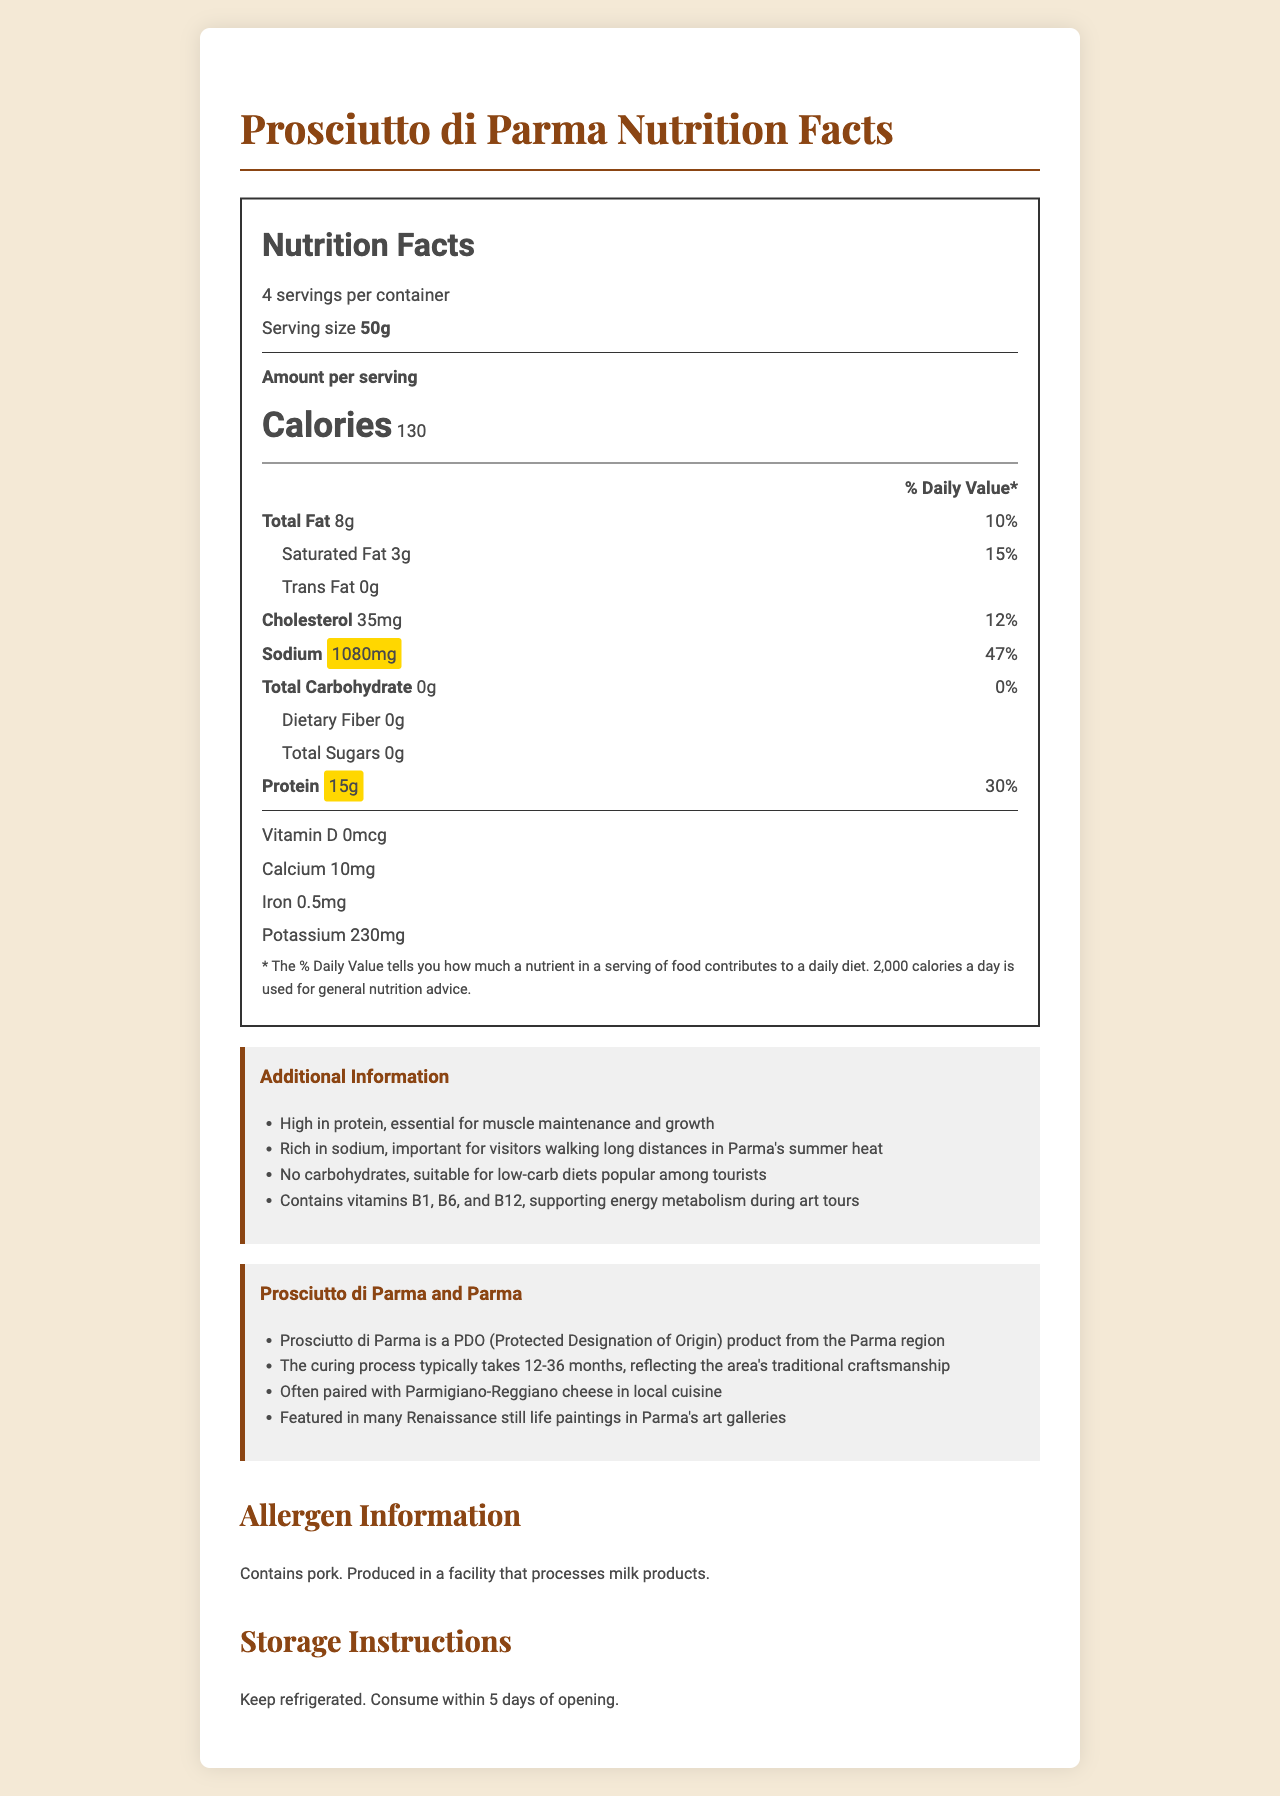what is the serving size for Prosciutto di Parma? The serving size is clearly stated as 50g in the document.
Answer: 50g how much protein does one serving of Prosciutto di Parma contain? The document indicates that each serving of Prosciutto di Parma contains 15g of protein.
Answer: 15g what is the daily value percentage of sodium in one serving? The sodium daily value percentage for one serving is given as 47% in the document.
Answer: 47% how many servings are in one container of Prosciutto di Parma? The document states that there are 4 servings per container.
Answer: 4 what is the cholesterol content per serving? Each serving contains 35mg of cholesterol as specified in the document.
Answer: 35mg which vitamin content is zero in Prosciutto di Parma? A. Vitamin D B. Vitamin C C. Calcium The document lists Vitamin D as having 0mcg.
Answer: A how does Prosciutto di Parma compare in sodium content with other typical foods? A. Low sodium B. Moderate sodium C. High sodium The highlighted amount of 1080mg of sodium per serving indicates it is high in sodium.
Answer: C can Prosciutto di Parma be a good option for a low-carb diet? Yes/No The document notes that Prosciutto di Parma contains 0g of total carbohydrates, making it suitable for low-carb diets.
Answer: Yes describe the main information provided in the document. The document outlines nutritional content, serving details, allergen and storage information, and provides cultural context.
Answer: The document provides detailed nutrition facts for Prosciutto di Parma, including serving size, calorie count, and the amounts and daily values of various nutrients such as fat, cholesterol, sodium, and protein. Additionally, it contains information on allergens, storage instructions, and its cultural significance and usage in Parma. what is the iron content per serving? The document states that each serving contains 0.5mg of iron.
Answer: 0.5mg what is the recommended storage instruction after opening? The storage instructions listed in the document are to keep the product refrigerated and consume it within 5 days of opening.
Answer: Keep refrigerated and consume within 5 days of opening. why is the sodium level highlighted in the nutrition facts? The sodium content is highlighted to emphasize that it is significantly high, making up 47% of the daily recommended value.
Answer: It's high at 1080mg per serving, contributing to 47% of the daily value. which vitamins are mentioned in the additional information but not listed in the nutrition facts table? A. B1, B6, and B12 B. A, C, and D C. D, E, and K The additional information section mentions B1, B6, and B12 vitamins, which are not detailed in the nutrition facts table.
Answer: A what is the daily value percentage of protein per serving? The daily value percentage for protein given in the document is 30%.
Answer: 30% can you determine how many grams of total carbohydrates are in a serving? The total carbohydrate content per serving is clearly stated as 0g in the document.
Answer: 0g what is the main use case of high sodium content, as mentioned in the document? The document mentions that the high sodium content is significant for visitors walking long distances in the summer heat of Parma.
Answer: Important for visitors walking long distances in Parma's summer heat. is Prosciutto di Parma suitable for people with milk allergies? The allergen information states it is produced in a facility that processes milk, but does not clearly state if it is suitable or not for people with milk allergies.
Answer: Cannot be determined 